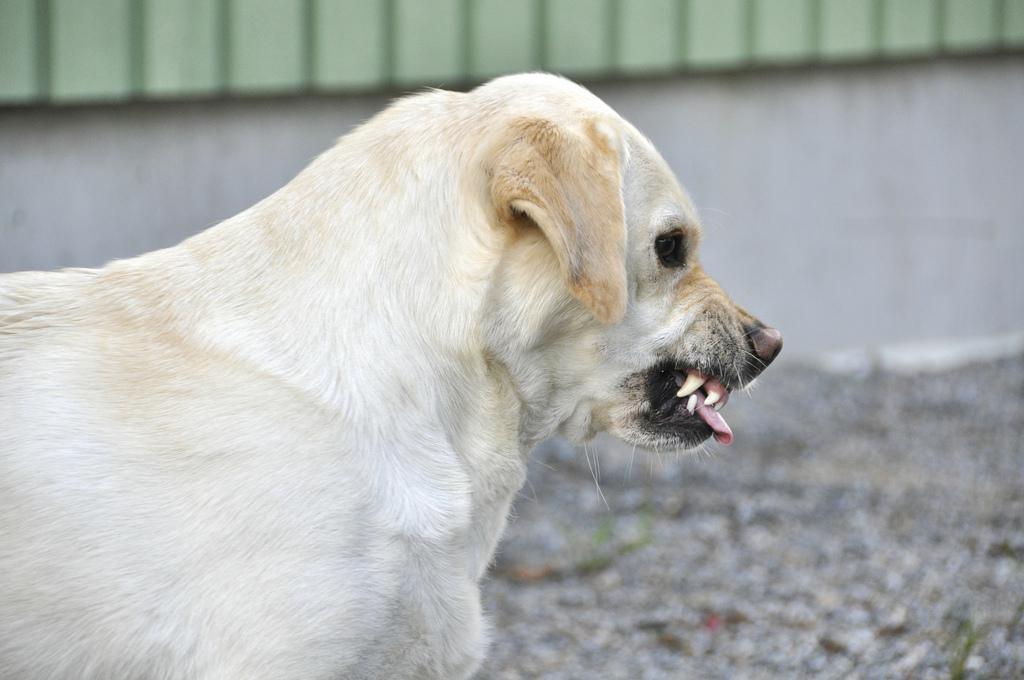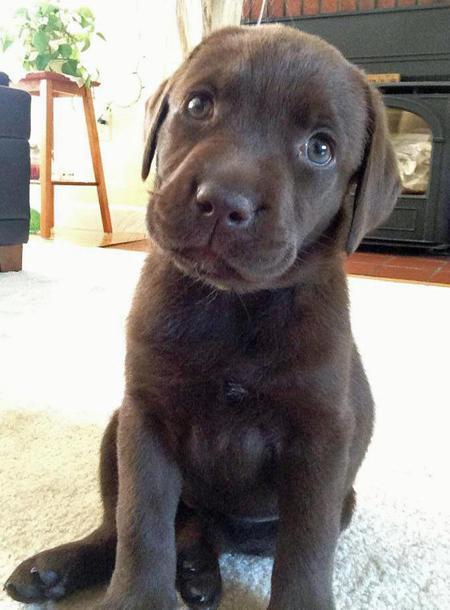The first image is the image on the left, the second image is the image on the right. For the images shown, is this caption "One of the images contains a puppy." true? Answer yes or no. Yes. The first image is the image on the left, the second image is the image on the right. Evaluate the accuracy of this statement regarding the images: "An image shows an upright yellow lab baring its fangs, but not wearing any collar or muzzle.". Is it true? Answer yes or no. Yes. 